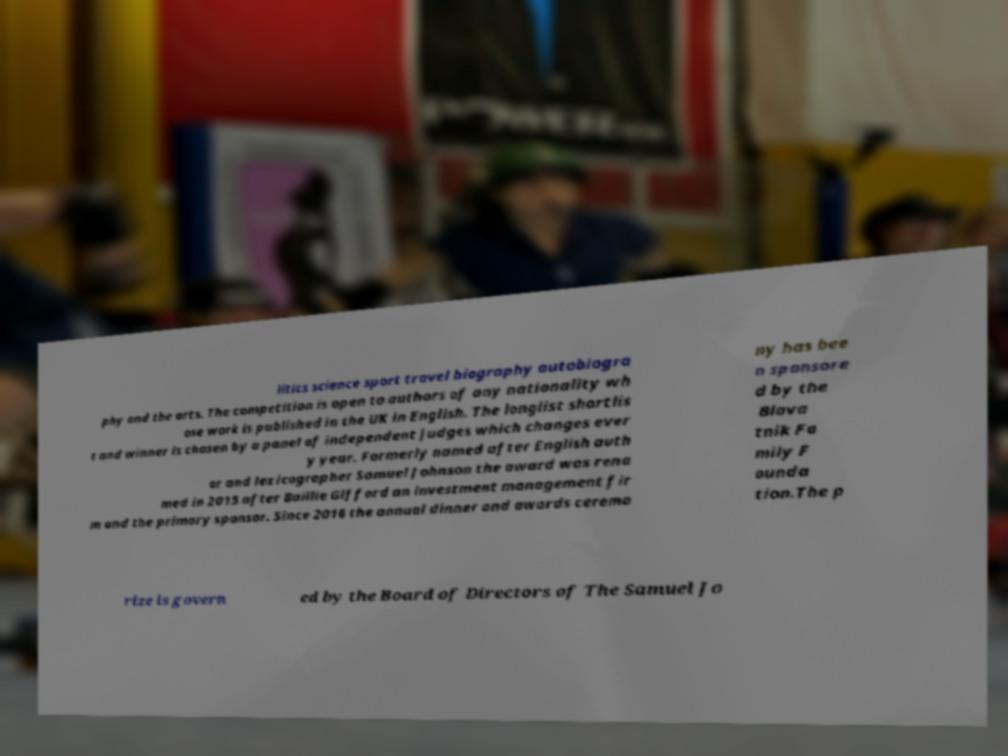Can you read and provide the text displayed in the image?This photo seems to have some interesting text. Can you extract and type it out for me? litics science sport travel biography autobiogra phy and the arts. The competition is open to authors of any nationality wh ose work is published in the UK in English. The longlist shortlis t and winner is chosen by a panel of independent judges which changes ever y year. Formerly named after English auth or and lexicographer Samuel Johnson the award was rena med in 2015 after Baillie Gifford an investment management fir m and the primary sponsor. Since 2016 the annual dinner and awards ceremo ny has bee n sponsore d by the Blava tnik Fa mily F ounda tion.The p rize is govern ed by the Board of Directors of The Samuel Jo 